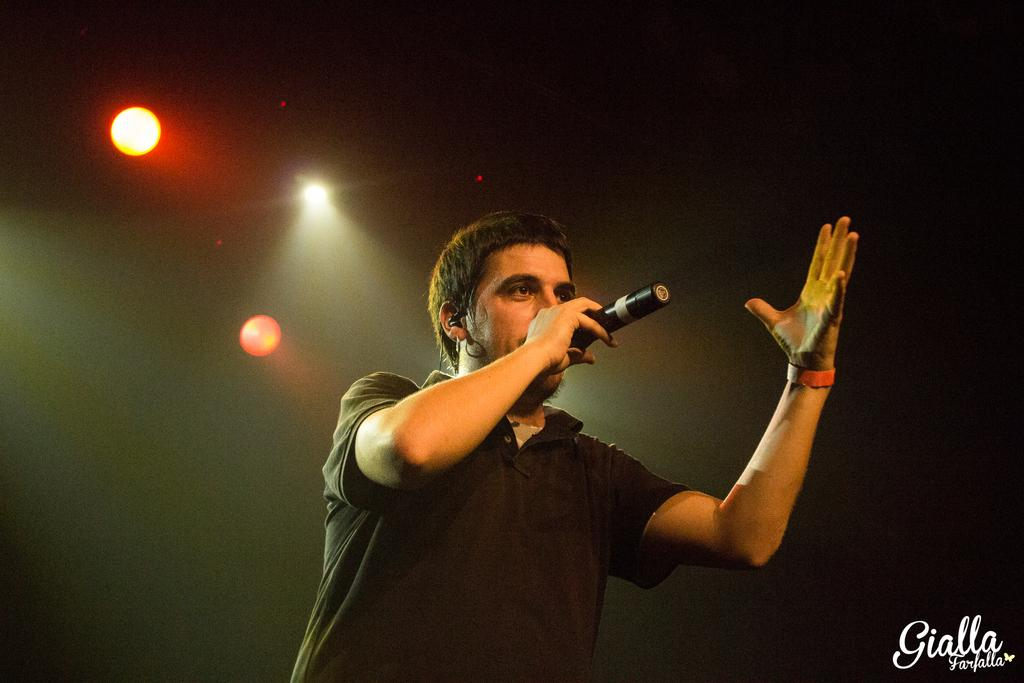Who is the main subject in the image? There is a man in the image. What is the man holding in the image? The man is holding a microphone. What is the man doing in the image? The man is singing. How many rings does the man have on his fingers in the image? There is no mention of rings in the image. 